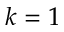<formula> <loc_0><loc_0><loc_500><loc_500>k = 1</formula> 